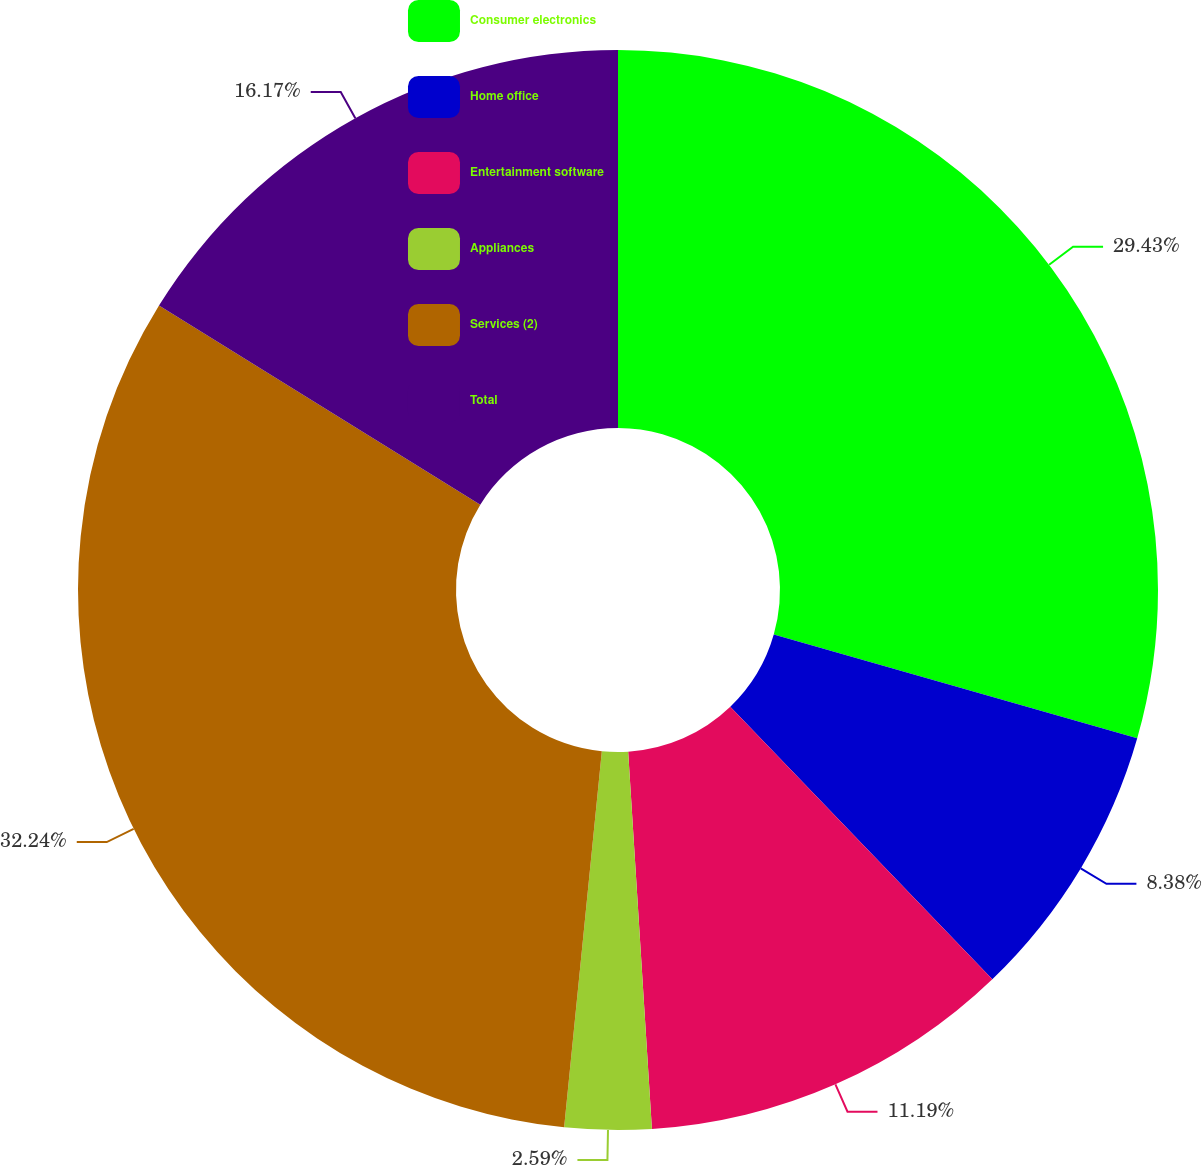Convert chart. <chart><loc_0><loc_0><loc_500><loc_500><pie_chart><fcel>Consumer electronics<fcel>Home office<fcel>Entertainment software<fcel>Appliances<fcel>Services (2)<fcel>Total<nl><fcel>29.43%<fcel>8.38%<fcel>11.19%<fcel>2.59%<fcel>32.24%<fcel>16.17%<nl></chart> 